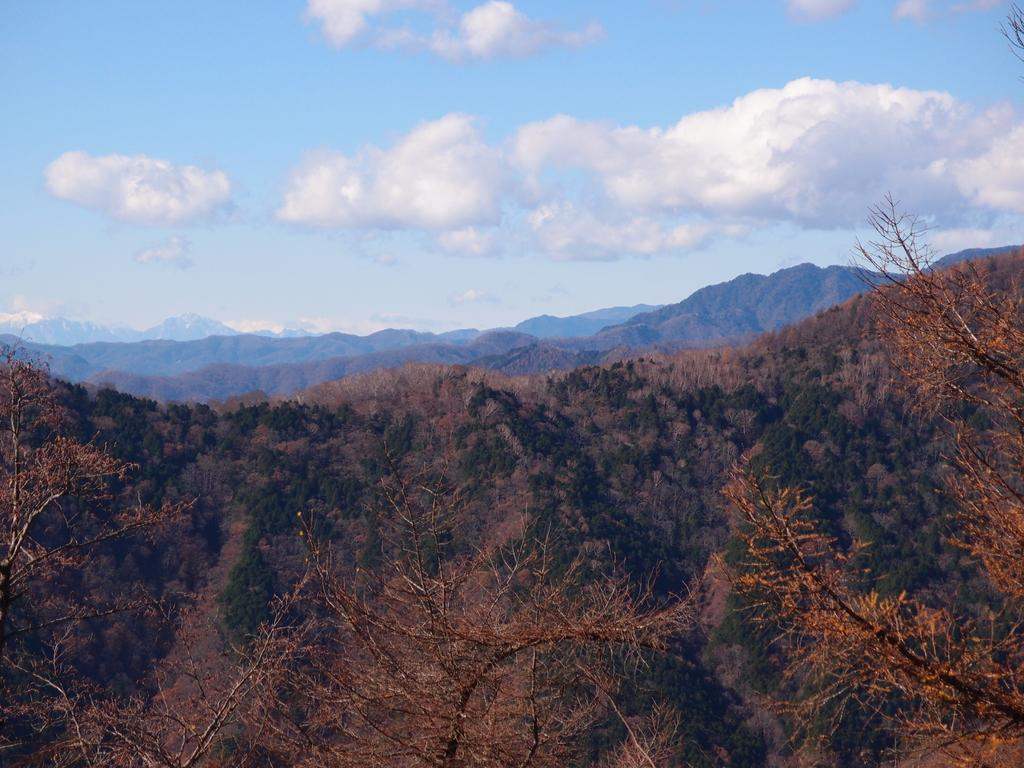What type of vegetation is present at the bottom of the image? There are trees at the bottom of the image. What geographical features can be seen in the background of the image? There are hills in the background of the image. What part of the natural environment is visible in the background of the image? The sky is visible in the background of the image. What type of insect is participating in the discussion in the image? There is no insect or discussion present in the image. 